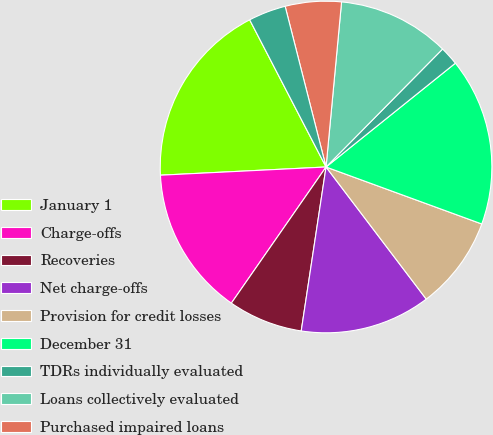<chart> <loc_0><loc_0><loc_500><loc_500><pie_chart><fcel>January 1<fcel>Charge-offs<fcel>Recoveries<fcel>Net charge-offs<fcel>Provision for credit losses<fcel>December 31<fcel>TDRs individually evaluated<fcel>Loans collectively evaluated<fcel>Purchased impaired loans<fcel>Portfolio segment ALLL as a<nl><fcel>18.17%<fcel>14.54%<fcel>7.28%<fcel>12.72%<fcel>9.09%<fcel>16.35%<fcel>1.83%<fcel>10.91%<fcel>5.46%<fcel>3.65%<nl></chart> 